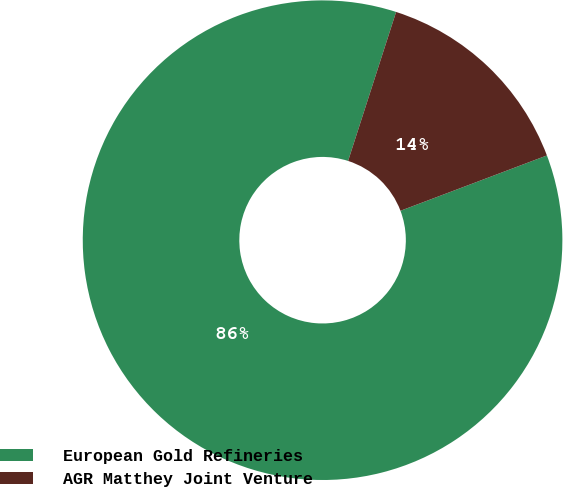Convert chart to OTSL. <chart><loc_0><loc_0><loc_500><loc_500><pie_chart><fcel>European Gold Refineries<fcel>AGR Matthey Joint Venture<nl><fcel>85.71%<fcel>14.29%<nl></chart> 